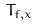Convert formula to latex. <formula><loc_0><loc_0><loc_500><loc_500>T _ { f , x }</formula> 